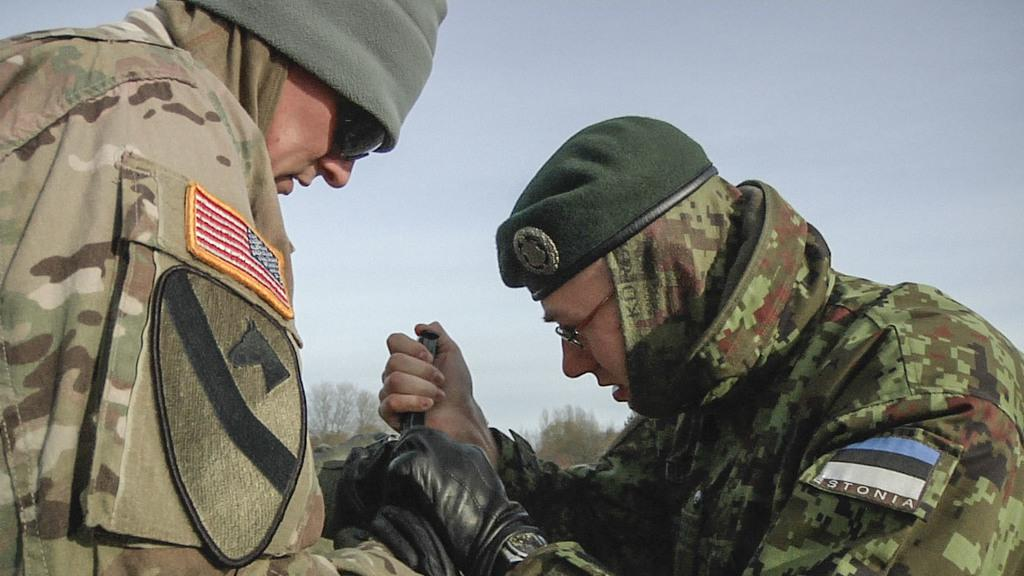How many soldiers are present in the image? There are two soldiers in the image. What is the second soldier holding in his hand? The second soldier is holding an object in his hand. What type of clothing are the soldiers wearing on their hands? Both soldiers are wearing gloves. What book is the soldier reading in the image? There is no book present in the image; the soldiers are not depicted reading. 